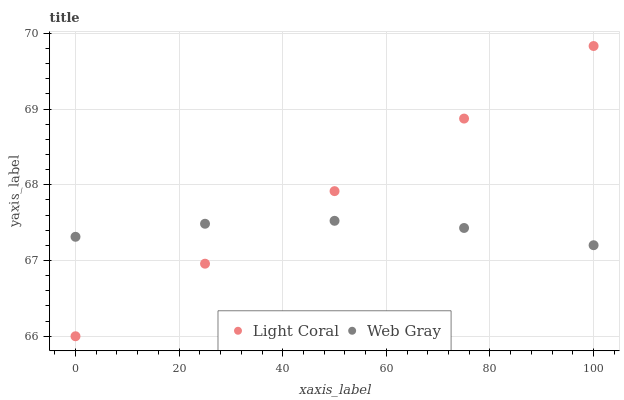Does Web Gray have the minimum area under the curve?
Answer yes or no. Yes. Does Light Coral have the maximum area under the curve?
Answer yes or no. Yes. Does Web Gray have the maximum area under the curve?
Answer yes or no. No. Is Light Coral the smoothest?
Answer yes or no. Yes. Is Web Gray the roughest?
Answer yes or no. Yes. Is Web Gray the smoothest?
Answer yes or no. No. Does Light Coral have the lowest value?
Answer yes or no. Yes. Does Web Gray have the lowest value?
Answer yes or no. No. Does Light Coral have the highest value?
Answer yes or no. Yes. Does Web Gray have the highest value?
Answer yes or no. No. Does Web Gray intersect Light Coral?
Answer yes or no. Yes. Is Web Gray less than Light Coral?
Answer yes or no. No. Is Web Gray greater than Light Coral?
Answer yes or no. No. 